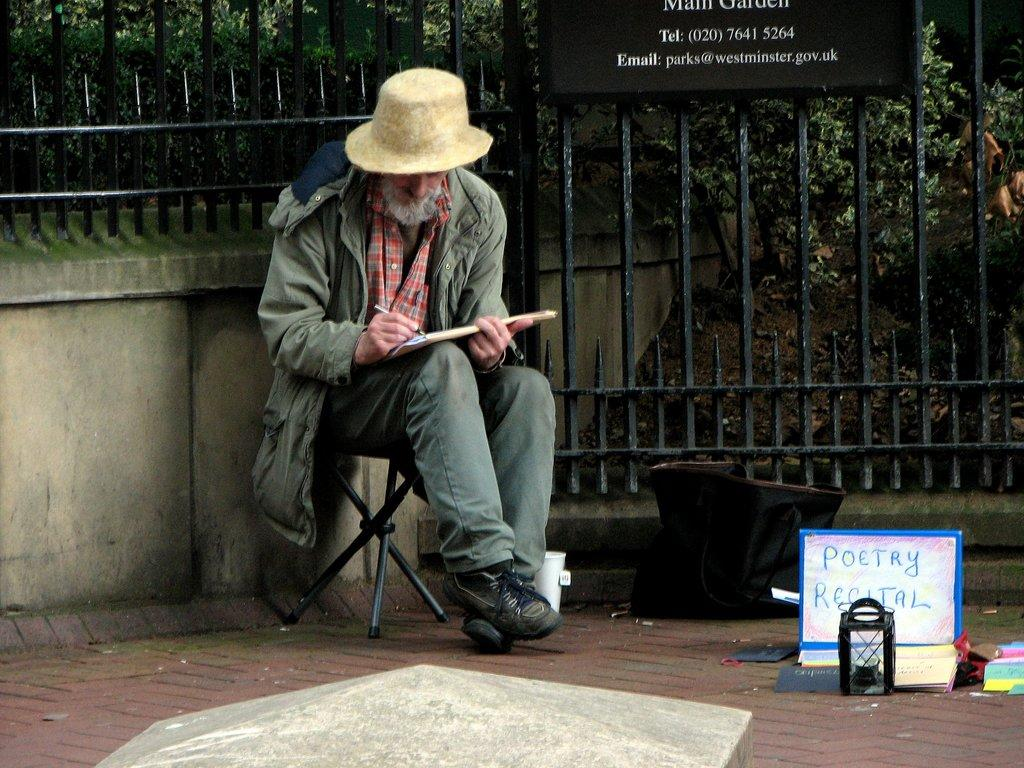Who is present in the image? There is a man in the image. What is the man doing in the image? The man is sitting on a chair. What can be seen behind the man? There is a fence behind the man. What is visible in the background of the image? There are trees in the background of the image. What type of grape is being used to make the jam on the table in the image? There is no table, grape, or jam present in the image; it only features a man sitting on a chair with a fence behind him and trees in the background. 